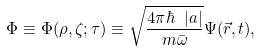Convert formula to latex. <formula><loc_0><loc_0><loc_500><loc_500>\Phi \equiv \Phi ( \rho , \zeta ; \tau ) \equiv \sqrt { \frac { 4 \pi \hbar { \ } | a | } { m \bar { \omega } } } \Psi ( \vec { r } , t ) ,</formula> 